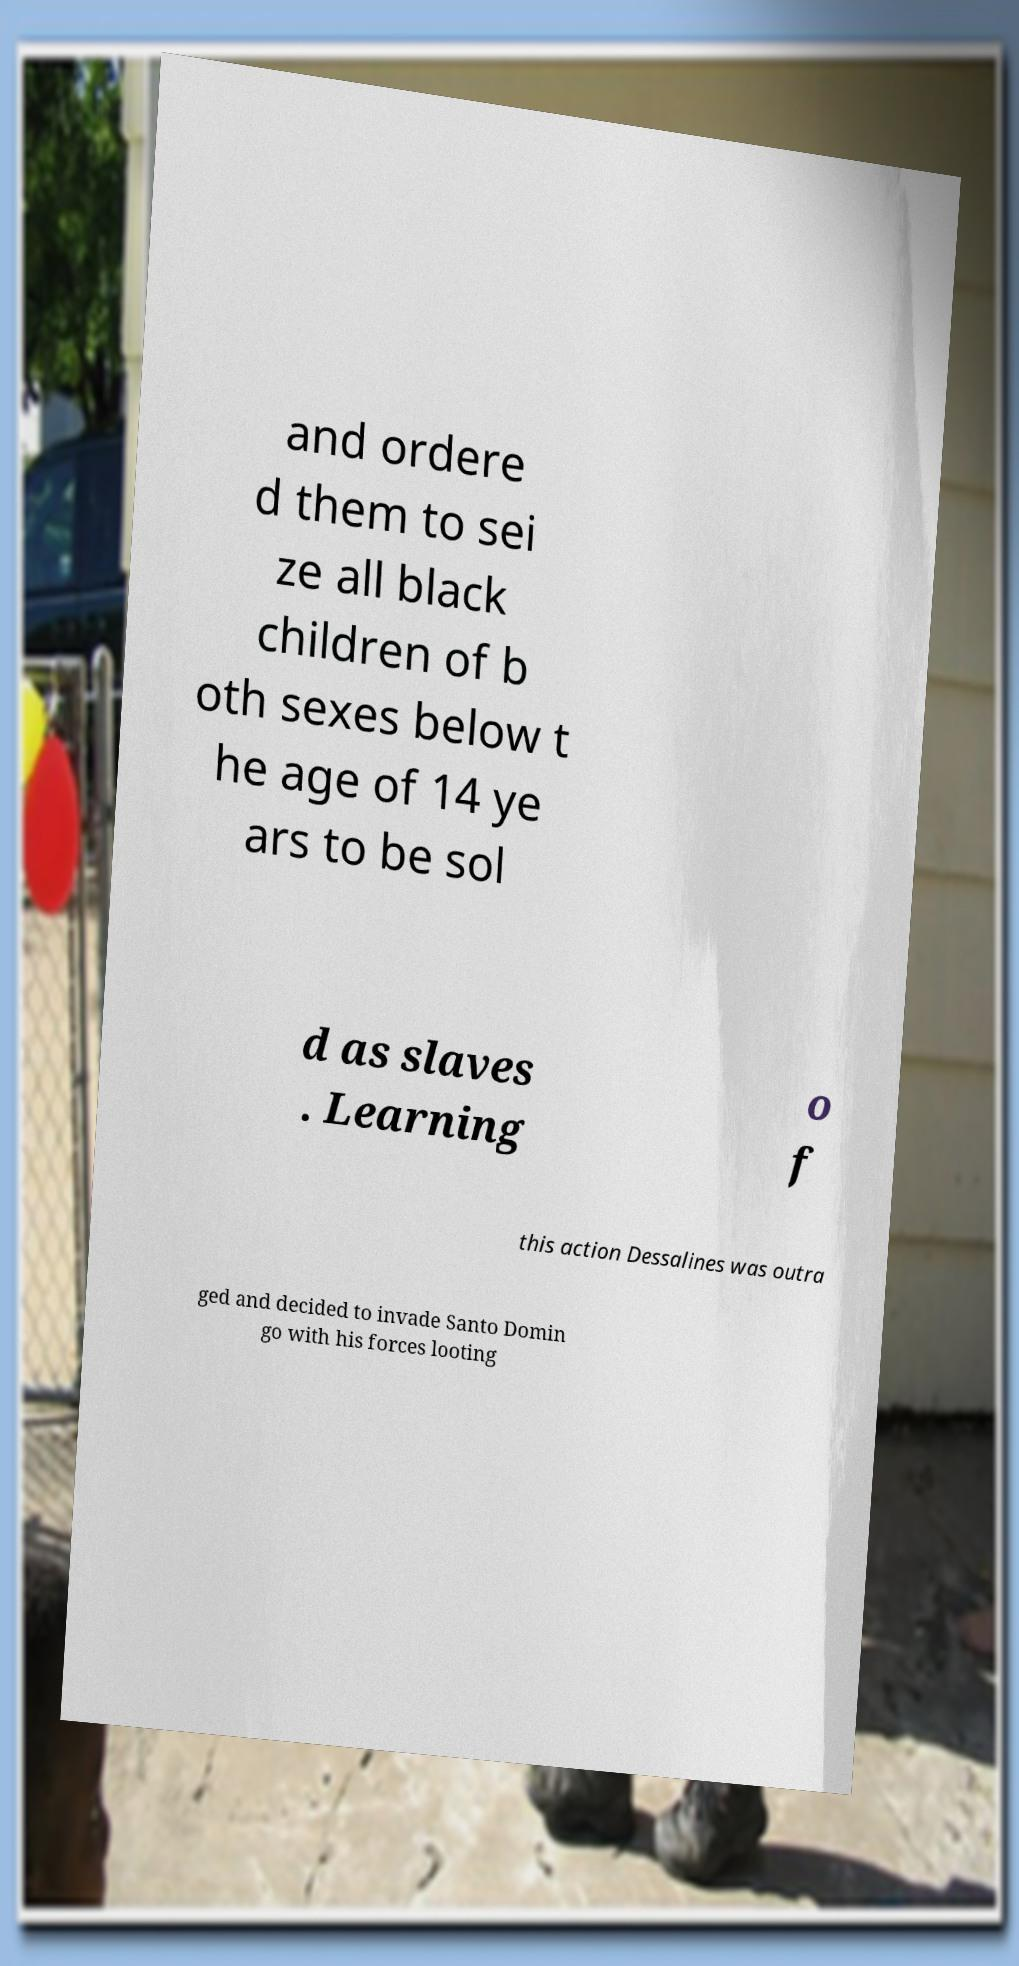Could you extract and type out the text from this image? and ordere d them to sei ze all black children of b oth sexes below t he age of 14 ye ars to be sol d as slaves . Learning o f this action Dessalines was outra ged and decided to invade Santo Domin go with his forces looting 